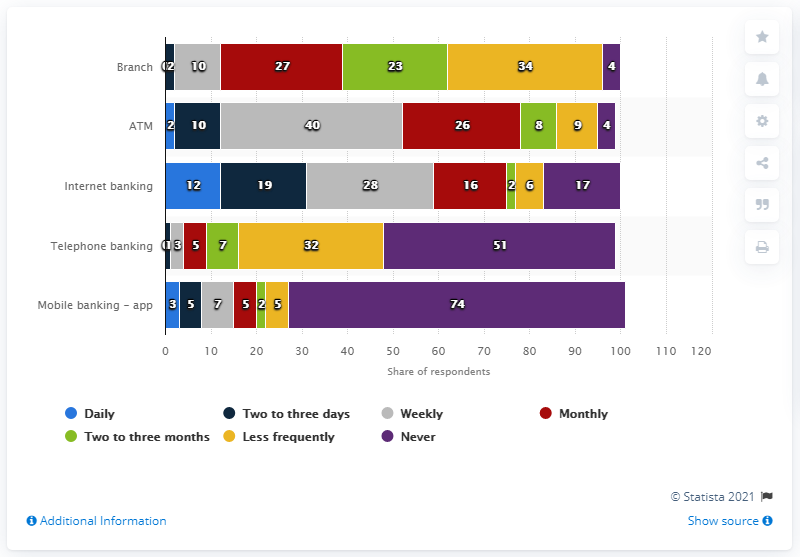List a handful of essential elements in this visual. According to a recent study, 28% of UK customers use internet banking on a weekly basis. 